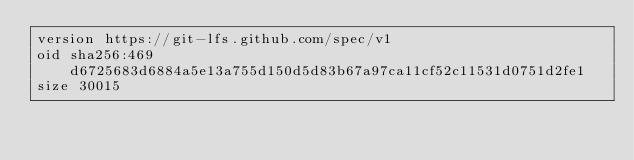Convert code to text. <code><loc_0><loc_0><loc_500><loc_500><_HTML_>version https://git-lfs.github.com/spec/v1
oid sha256:469d6725683d6884a5e13a755d150d5d83b67a97ca11cf52c11531d0751d2fe1
size 30015
</code> 